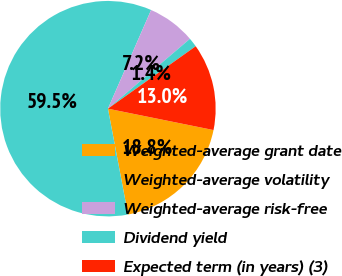<chart> <loc_0><loc_0><loc_500><loc_500><pie_chart><fcel>Weighted-average grant date<fcel>Weighted-average volatility<fcel>Weighted-average risk-free<fcel>Dividend yield<fcel>Expected term (in years) (3)<nl><fcel>18.84%<fcel>59.55%<fcel>7.21%<fcel>1.39%<fcel>13.02%<nl></chart> 